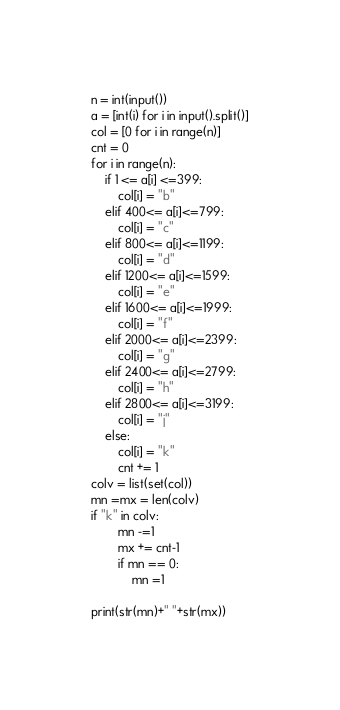Convert code to text. <code><loc_0><loc_0><loc_500><loc_500><_Python_>n = int(input())
a = [int(i) for i in input().split()]
col = [0 for i in range(n)]
cnt = 0
for i in range(n):
    if 1 <= a[i] <=399:
        col[i] = "b"
    elif 400<= a[i]<=799:
        col[i] = "c"
    elif 800<= a[i]<=1199:
        col[i] = "d"
    elif 1200<= a[i]<=1599:
        col[i] = "e"
    elif 1600<= a[i]<=1999:
        col[i] = "f"
    elif 2000<= a[i]<=2399:
        col[i] = "g"
    elif 2400<= a[i]<=2799:
        col[i] = "h"
    elif 2800<= a[i]<=3199:
        col[i] = "j"
    else:
        col[i] = "k"
        cnt += 1
colv = list(set(col))
mn =mx = len(colv)
if "k" in colv:
        mn -=1
        mx += cnt-1
        if mn == 0:
            mn =1
        
print(str(mn)+" "+str(mx))</code> 